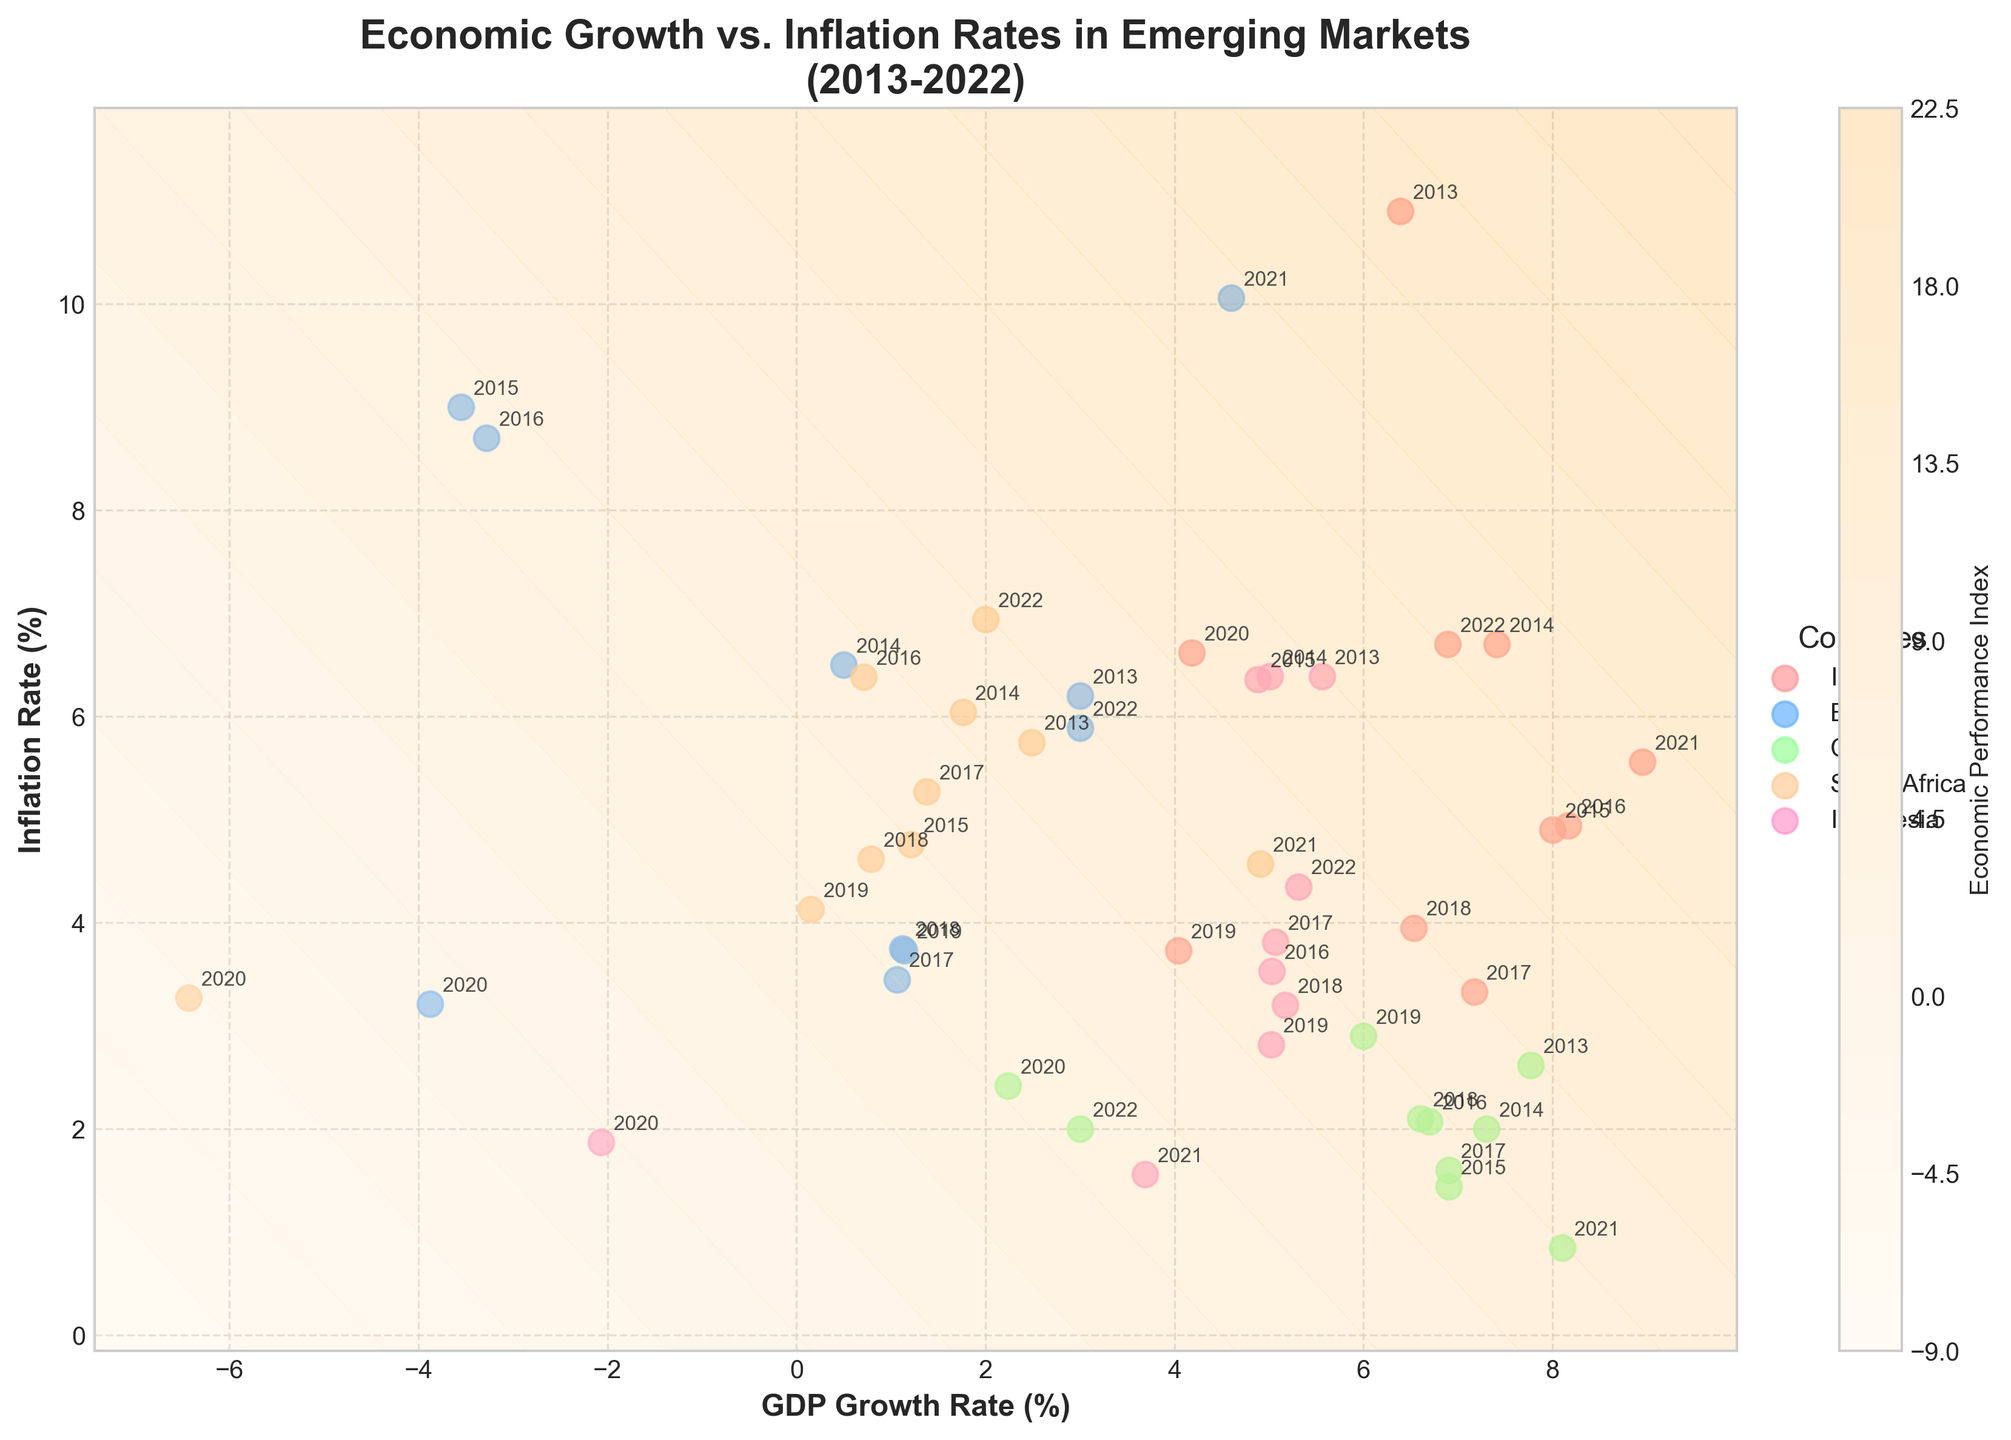What is the general trend of GDP growth rate versus inflation rate in India over the last decade? The scatter plot for India shows that while the GDP growth rate peaked around 2015 and 2016 and then declined, the inflation rate generally decreased from 2013 to 2019, briefly rose in 2020, and fluctuated around 5-6% in recent years. This indicates that higher GDP growth generally corresponded with lower inflation rates for India in the given timeframe.
Answer: Inverse relationship Which country had the highest GDP growth rate in 2021? By looking at the scatter plot, China's data point has the highest position on the x-axis in 2021, indicating the highest GDP growth rate.
Answer: China How did South Africa's GDP growth rate and inflation rate change from 2019 to 2020? Observing the data points for South Africa, there is a sharp drop in GDP growth rate from 0.15% in 2019 to -6.43% in 2020. The inflation rate also decreased from 4.13% in 2019 to 3.27% in 2020.
Answer: GDP growth rate declined, inflation rate declined Compare Brazil's economic performance index levels between 2015 and 2021. Which year had a worse performance? The contour plot shows the economic performance index increasing with higher combined values of GDP growth and inflation. In 2015, Brazil had a -3.55 % GDP growth rate and a 9% inflation rate, while in 2021, it had a 4.60% GDP growth rate and a 10.06% inflation rate. The index value will be higher in 2021 (4.60 + 10.06 > -3.55 + 9), indicating a worse performance in 2015.
Answer: 2015 Which country's data points show a relatively stable inflation rate over the decade? Amongst the countries displayed, China's inflation rate shows the least variability across the years, consistently ranging from around 0.85% to 2.9%.
Answer: China What was the highest Inflation Rate recorded, and which country does it belong to? Looking through the scatter points, the highest inflation rate is approximately 10.90%, recorded by India in 2013.
Answer: India in 2013 Which country experienced the poorest GDP growth in any year, and what was the rate? The scatter plot shows South Africa experienced the poorest GDP growth in 2020 with a rate of -6.43%.
Answer: South Africa, -6.43% 